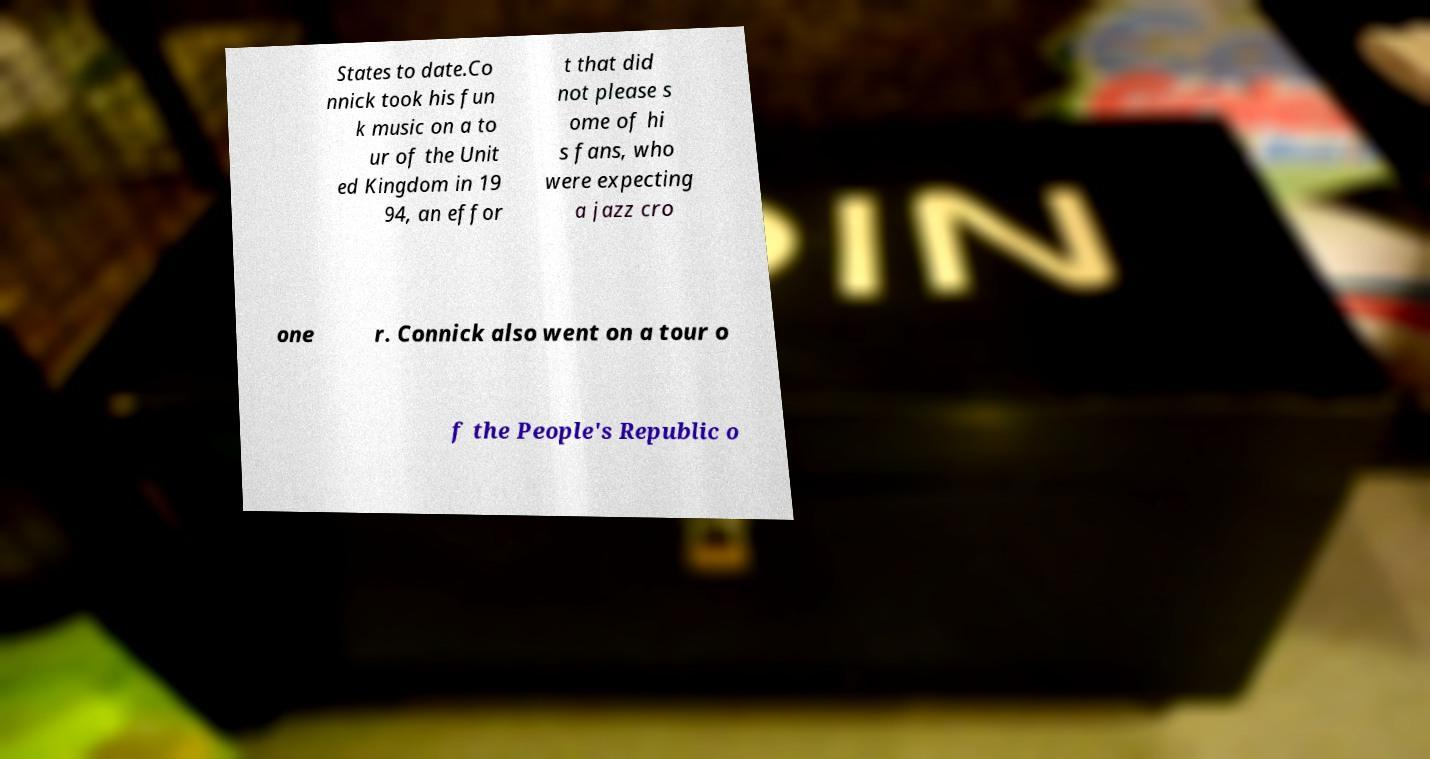I need the written content from this picture converted into text. Can you do that? States to date.Co nnick took his fun k music on a to ur of the Unit ed Kingdom in 19 94, an effor t that did not please s ome of hi s fans, who were expecting a jazz cro one r. Connick also went on a tour o f the People's Republic o 